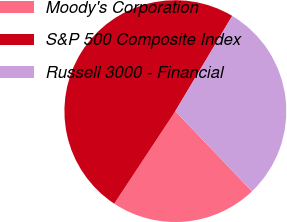Convert chart to OTSL. <chart><loc_0><loc_0><loc_500><loc_500><pie_chart><fcel>Moody's Corporation<fcel>S&P 500 Composite Index<fcel>Russell 3000 - Financial<nl><fcel>21.43%<fcel>49.28%<fcel>29.29%<nl></chart> 